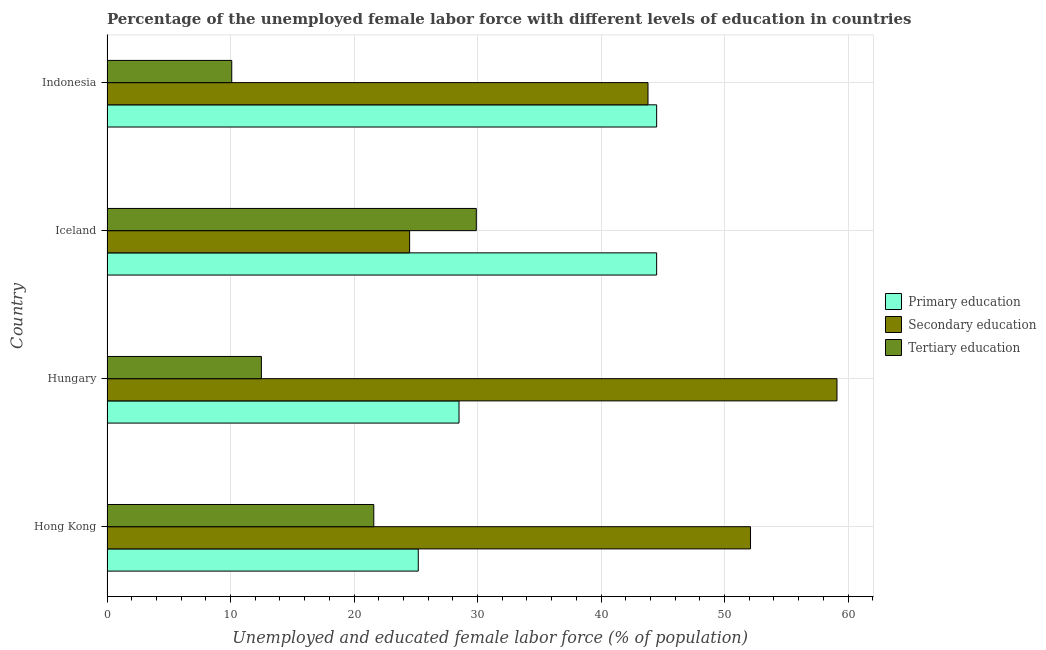How many different coloured bars are there?
Give a very brief answer. 3. How many groups of bars are there?
Provide a succinct answer. 4. How many bars are there on the 2nd tick from the top?
Ensure brevity in your answer.  3. What is the label of the 1st group of bars from the top?
Ensure brevity in your answer.  Indonesia. What is the percentage of female labor force who received secondary education in Hungary?
Offer a terse response. 59.1. Across all countries, what is the maximum percentage of female labor force who received tertiary education?
Make the answer very short. 29.9. Across all countries, what is the minimum percentage of female labor force who received tertiary education?
Your answer should be very brief. 10.1. In which country was the percentage of female labor force who received tertiary education maximum?
Provide a short and direct response. Iceland. What is the total percentage of female labor force who received secondary education in the graph?
Offer a terse response. 179.5. What is the difference between the percentage of female labor force who received primary education in Hong Kong and the percentage of female labor force who received tertiary education in Indonesia?
Offer a very short reply. 15.1. What is the average percentage of female labor force who received primary education per country?
Provide a short and direct response. 35.67. What is the difference between the percentage of female labor force who received secondary education and percentage of female labor force who received primary education in Iceland?
Your answer should be compact. -20. What is the ratio of the percentage of female labor force who received tertiary education in Hong Kong to that in Hungary?
Keep it short and to the point. 1.73. What is the difference between the highest and the lowest percentage of female labor force who received secondary education?
Offer a very short reply. 34.6. Is the sum of the percentage of female labor force who received primary education in Hong Kong and Indonesia greater than the maximum percentage of female labor force who received tertiary education across all countries?
Offer a terse response. Yes. What does the 3rd bar from the bottom in Hungary represents?
Provide a succinct answer. Tertiary education. Is it the case that in every country, the sum of the percentage of female labor force who received primary education and percentage of female labor force who received secondary education is greater than the percentage of female labor force who received tertiary education?
Your response must be concise. Yes. Are all the bars in the graph horizontal?
Your response must be concise. Yes. What is the difference between two consecutive major ticks on the X-axis?
Your response must be concise. 10. Are the values on the major ticks of X-axis written in scientific E-notation?
Ensure brevity in your answer.  No. Does the graph contain any zero values?
Offer a terse response. No. Does the graph contain grids?
Offer a very short reply. Yes. Where does the legend appear in the graph?
Make the answer very short. Center right. How many legend labels are there?
Give a very brief answer. 3. What is the title of the graph?
Make the answer very short. Percentage of the unemployed female labor force with different levels of education in countries. Does "Methane" appear as one of the legend labels in the graph?
Offer a terse response. No. What is the label or title of the X-axis?
Provide a succinct answer. Unemployed and educated female labor force (% of population). What is the label or title of the Y-axis?
Make the answer very short. Country. What is the Unemployed and educated female labor force (% of population) in Primary education in Hong Kong?
Give a very brief answer. 25.2. What is the Unemployed and educated female labor force (% of population) in Secondary education in Hong Kong?
Offer a terse response. 52.1. What is the Unemployed and educated female labor force (% of population) of Tertiary education in Hong Kong?
Your response must be concise. 21.6. What is the Unemployed and educated female labor force (% of population) of Primary education in Hungary?
Your response must be concise. 28.5. What is the Unemployed and educated female labor force (% of population) of Secondary education in Hungary?
Offer a very short reply. 59.1. What is the Unemployed and educated female labor force (% of population) of Tertiary education in Hungary?
Offer a very short reply. 12.5. What is the Unemployed and educated female labor force (% of population) in Primary education in Iceland?
Provide a succinct answer. 44.5. What is the Unemployed and educated female labor force (% of population) of Tertiary education in Iceland?
Offer a terse response. 29.9. What is the Unemployed and educated female labor force (% of population) in Primary education in Indonesia?
Make the answer very short. 44.5. What is the Unemployed and educated female labor force (% of population) of Secondary education in Indonesia?
Keep it short and to the point. 43.8. What is the Unemployed and educated female labor force (% of population) of Tertiary education in Indonesia?
Provide a succinct answer. 10.1. Across all countries, what is the maximum Unemployed and educated female labor force (% of population) of Primary education?
Provide a short and direct response. 44.5. Across all countries, what is the maximum Unemployed and educated female labor force (% of population) of Secondary education?
Give a very brief answer. 59.1. Across all countries, what is the maximum Unemployed and educated female labor force (% of population) of Tertiary education?
Your response must be concise. 29.9. Across all countries, what is the minimum Unemployed and educated female labor force (% of population) of Primary education?
Make the answer very short. 25.2. Across all countries, what is the minimum Unemployed and educated female labor force (% of population) of Secondary education?
Offer a very short reply. 24.5. Across all countries, what is the minimum Unemployed and educated female labor force (% of population) in Tertiary education?
Make the answer very short. 10.1. What is the total Unemployed and educated female labor force (% of population) in Primary education in the graph?
Make the answer very short. 142.7. What is the total Unemployed and educated female labor force (% of population) in Secondary education in the graph?
Your answer should be compact. 179.5. What is the total Unemployed and educated female labor force (% of population) of Tertiary education in the graph?
Your response must be concise. 74.1. What is the difference between the Unemployed and educated female labor force (% of population) of Tertiary education in Hong Kong and that in Hungary?
Give a very brief answer. 9.1. What is the difference between the Unemployed and educated female labor force (% of population) in Primary education in Hong Kong and that in Iceland?
Provide a short and direct response. -19.3. What is the difference between the Unemployed and educated female labor force (% of population) of Secondary education in Hong Kong and that in Iceland?
Offer a very short reply. 27.6. What is the difference between the Unemployed and educated female labor force (% of population) in Primary education in Hong Kong and that in Indonesia?
Provide a succinct answer. -19.3. What is the difference between the Unemployed and educated female labor force (% of population) in Tertiary education in Hong Kong and that in Indonesia?
Offer a terse response. 11.5. What is the difference between the Unemployed and educated female labor force (% of population) of Primary education in Hungary and that in Iceland?
Provide a succinct answer. -16. What is the difference between the Unemployed and educated female labor force (% of population) of Secondary education in Hungary and that in Iceland?
Provide a short and direct response. 34.6. What is the difference between the Unemployed and educated female labor force (% of population) of Tertiary education in Hungary and that in Iceland?
Give a very brief answer. -17.4. What is the difference between the Unemployed and educated female labor force (% of population) of Secondary education in Hungary and that in Indonesia?
Keep it short and to the point. 15.3. What is the difference between the Unemployed and educated female labor force (% of population) of Tertiary education in Hungary and that in Indonesia?
Offer a very short reply. 2.4. What is the difference between the Unemployed and educated female labor force (% of population) of Primary education in Iceland and that in Indonesia?
Your answer should be compact. 0. What is the difference between the Unemployed and educated female labor force (% of population) in Secondary education in Iceland and that in Indonesia?
Offer a terse response. -19.3. What is the difference between the Unemployed and educated female labor force (% of population) of Tertiary education in Iceland and that in Indonesia?
Your answer should be very brief. 19.8. What is the difference between the Unemployed and educated female labor force (% of population) in Primary education in Hong Kong and the Unemployed and educated female labor force (% of population) in Secondary education in Hungary?
Provide a short and direct response. -33.9. What is the difference between the Unemployed and educated female labor force (% of population) in Primary education in Hong Kong and the Unemployed and educated female labor force (% of population) in Tertiary education in Hungary?
Ensure brevity in your answer.  12.7. What is the difference between the Unemployed and educated female labor force (% of population) of Secondary education in Hong Kong and the Unemployed and educated female labor force (% of population) of Tertiary education in Hungary?
Provide a short and direct response. 39.6. What is the difference between the Unemployed and educated female labor force (% of population) of Primary education in Hong Kong and the Unemployed and educated female labor force (% of population) of Tertiary education in Iceland?
Give a very brief answer. -4.7. What is the difference between the Unemployed and educated female labor force (% of population) of Primary education in Hong Kong and the Unemployed and educated female labor force (% of population) of Secondary education in Indonesia?
Provide a short and direct response. -18.6. What is the difference between the Unemployed and educated female labor force (% of population) in Secondary education in Hong Kong and the Unemployed and educated female labor force (% of population) in Tertiary education in Indonesia?
Your response must be concise. 42. What is the difference between the Unemployed and educated female labor force (% of population) in Primary education in Hungary and the Unemployed and educated female labor force (% of population) in Secondary education in Iceland?
Your answer should be very brief. 4. What is the difference between the Unemployed and educated female labor force (% of population) of Primary education in Hungary and the Unemployed and educated female labor force (% of population) of Tertiary education in Iceland?
Provide a succinct answer. -1.4. What is the difference between the Unemployed and educated female labor force (% of population) in Secondary education in Hungary and the Unemployed and educated female labor force (% of population) in Tertiary education in Iceland?
Make the answer very short. 29.2. What is the difference between the Unemployed and educated female labor force (% of population) of Primary education in Hungary and the Unemployed and educated female labor force (% of population) of Secondary education in Indonesia?
Provide a short and direct response. -15.3. What is the difference between the Unemployed and educated female labor force (% of population) of Secondary education in Hungary and the Unemployed and educated female labor force (% of population) of Tertiary education in Indonesia?
Your answer should be very brief. 49. What is the difference between the Unemployed and educated female labor force (% of population) of Primary education in Iceland and the Unemployed and educated female labor force (% of population) of Secondary education in Indonesia?
Provide a succinct answer. 0.7. What is the difference between the Unemployed and educated female labor force (% of population) of Primary education in Iceland and the Unemployed and educated female labor force (% of population) of Tertiary education in Indonesia?
Make the answer very short. 34.4. What is the difference between the Unemployed and educated female labor force (% of population) of Secondary education in Iceland and the Unemployed and educated female labor force (% of population) of Tertiary education in Indonesia?
Keep it short and to the point. 14.4. What is the average Unemployed and educated female labor force (% of population) of Primary education per country?
Offer a very short reply. 35.67. What is the average Unemployed and educated female labor force (% of population) in Secondary education per country?
Provide a short and direct response. 44.88. What is the average Unemployed and educated female labor force (% of population) of Tertiary education per country?
Offer a very short reply. 18.52. What is the difference between the Unemployed and educated female labor force (% of population) of Primary education and Unemployed and educated female labor force (% of population) of Secondary education in Hong Kong?
Your answer should be very brief. -26.9. What is the difference between the Unemployed and educated female labor force (% of population) of Secondary education and Unemployed and educated female labor force (% of population) of Tertiary education in Hong Kong?
Provide a short and direct response. 30.5. What is the difference between the Unemployed and educated female labor force (% of population) in Primary education and Unemployed and educated female labor force (% of population) in Secondary education in Hungary?
Keep it short and to the point. -30.6. What is the difference between the Unemployed and educated female labor force (% of population) in Primary education and Unemployed and educated female labor force (% of population) in Tertiary education in Hungary?
Make the answer very short. 16. What is the difference between the Unemployed and educated female labor force (% of population) of Secondary education and Unemployed and educated female labor force (% of population) of Tertiary education in Hungary?
Ensure brevity in your answer.  46.6. What is the difference between the Unemployed and educated female labor force (% of population) in Primary education and Unemployed and educated female labor force (% of population) in Secondary education in Iceland?
Provide a short and direct response. 20. What is the difference between the Unemployed and educated female labor force (% of population) of Secondary education and Unemployed and educated female labor force (% of population) of Tertiary education in Iceland?
Your answer should be very brief. -5.4. What is the difference between the Unemployed and educated female labor force (% of population) in Primary education and Unemployed and educated female labor force (% of population) in Tertiary education in Indonesia?
Ensure brevity in your answer.  34.4. What is the difference between the Unemployed and educated female labor force (% of population) in Secondary education and Unemployed and educated female labor force (% of population) in Tertiary education in Indonesia?
Offer a very short reply. 33.7. What is the ratio of the Unemployed and educated female labor force (% of population) in Primary education in Hong Kong to that in Hungary?
Your response must be concise. 0.88. What is the ratio of the Unemployed and educated female labor force (% of population) of Secondary education in Hong Kong to that in Hungary?
Give a very brief answer. 0.88. What is the ratio of the Unemployed and educated female labor force (% of population) in Tertiary education in Hong Kong to that in Hungary?
Your answer should be compact. 1.73. What is the ratio of the Unemployed and educated female labor force (% of population) of Primary education in Hong Kong to that in Iceland?
Make the answer very short. 0.57. What is the ratio of the Unemployed and educated female labor force (% of population) of Secondary education in Hong Kong to that in Iceland?
Offer a very short reply. 2.13. What is the ratio of the Unemployed and educated female labor force (% of population) of Tertiary education in Hong Kong to that in Iceland?
Make the answer very short. 0.72. What is the ratio of the Unemployed and educated female labor force (% of population) in Primary education in Hong Kong to that in Indonesia?
Provide a short and direct response. 0.57. What is the ratio of the Unemployed and educated female labor force (% of population) in Secondary education in Hong Kong to that in Indonesia?
Ensure brevity in your answer.  1.19. What is the ratio of the Unemployed and educated female labor force (% of population) in Tertiary education in Hong Kong to that in Indonesia?
Ensure brevity in your answer.  2.14. What is the ratio of the Unemployed and educated female labor force (% of population) of Primary education in Hungary to that in Iceland?
Your answer should be very brief. 0.64. What is the ratio of the Unemployed and educated female labor force (% of population) in Secondary education in Hungary to that in Iceland?
Your response must be concise. 2.41. What is the ratio of the Unemployed and educated female labor force (% of population) in Tertiary education in Hungary to that in Iceland?
Keep it short and to the point. 0.42. What is the ratio of the Unemployed and educated female labor force (% of population) in Primary education in Hungary to that in Indonesia?
Provide a succinct answer. 0.64. What is the ratio of the Unemployed and educated female labor force (% of population) of Secondary education in Hungary to that in Indonesia?
Your answer should be very brief. 1.35. What is the ratio of the Unemployed and educated female labor force (% of population) in Tertiary education in Hungary to that in Indonesia?
Your answer should be very brief. 1.24. What is the ratio of the Unemployed and educated female labor force (% of population) in Secondary education in Iceland to that in Indonesia?
Ensure brevity in your answer.  0.56. What is the ratio of the Unemployed and educated female labor force (% of population) of Tertiary education in Iceland to that in Indonesia?
Provide a succinct answer. 2.96. What is the difference between the highest and the second highest Unemployed and educated female labor force (% of population) in Secondary education?
Ensure brevity in your answer.  7. What is the difference between the highest and the second highest Unemployed and educated female labor force (% of population) in Tertiary education?
Provide a short and direct response. 8.3. What is the difference between the highest and the lowest Unemployed and educated female labor force (% of population) in Primary education?
Make the answer very short. 19.3. What is the difference between the highest and the lowest Unemployed and educated female labor force (% of population) of Secondary education?
Ensure brevity in your answer.  34.6. What is the difference between the highest and the lowest Unemployed and educated female labor force (% of population) of Tertiary education?
Offer a very short reply. 19.8. 